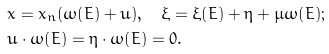Convert formula to latex. <formula><loc_0><loc_0><loc_500><loc_500>& x = x _ { n } { \left ( \omega { \left ( E \right ) } + u \right ) } , \quad \xi = \xi { \left ( E \right ) } + \eta + \mu \omega { \left ( E \right ) } ; \\ & u \cdot \omega { \left ( E \right ) } = \eta \cdot \omega { \left ( E \right ) } = 0 .</formula> 